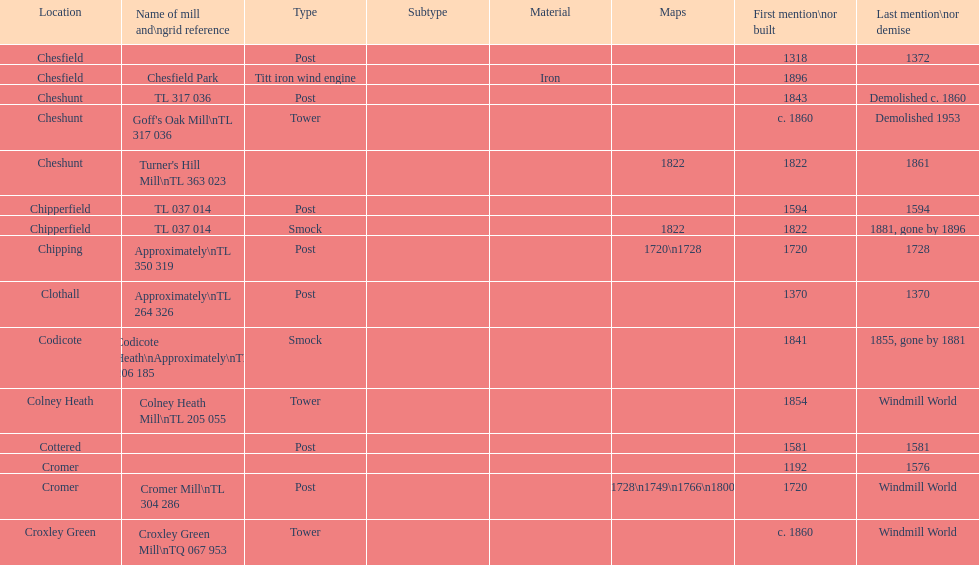What is the number of mills first mentioned or built in the 1800s? 8. 